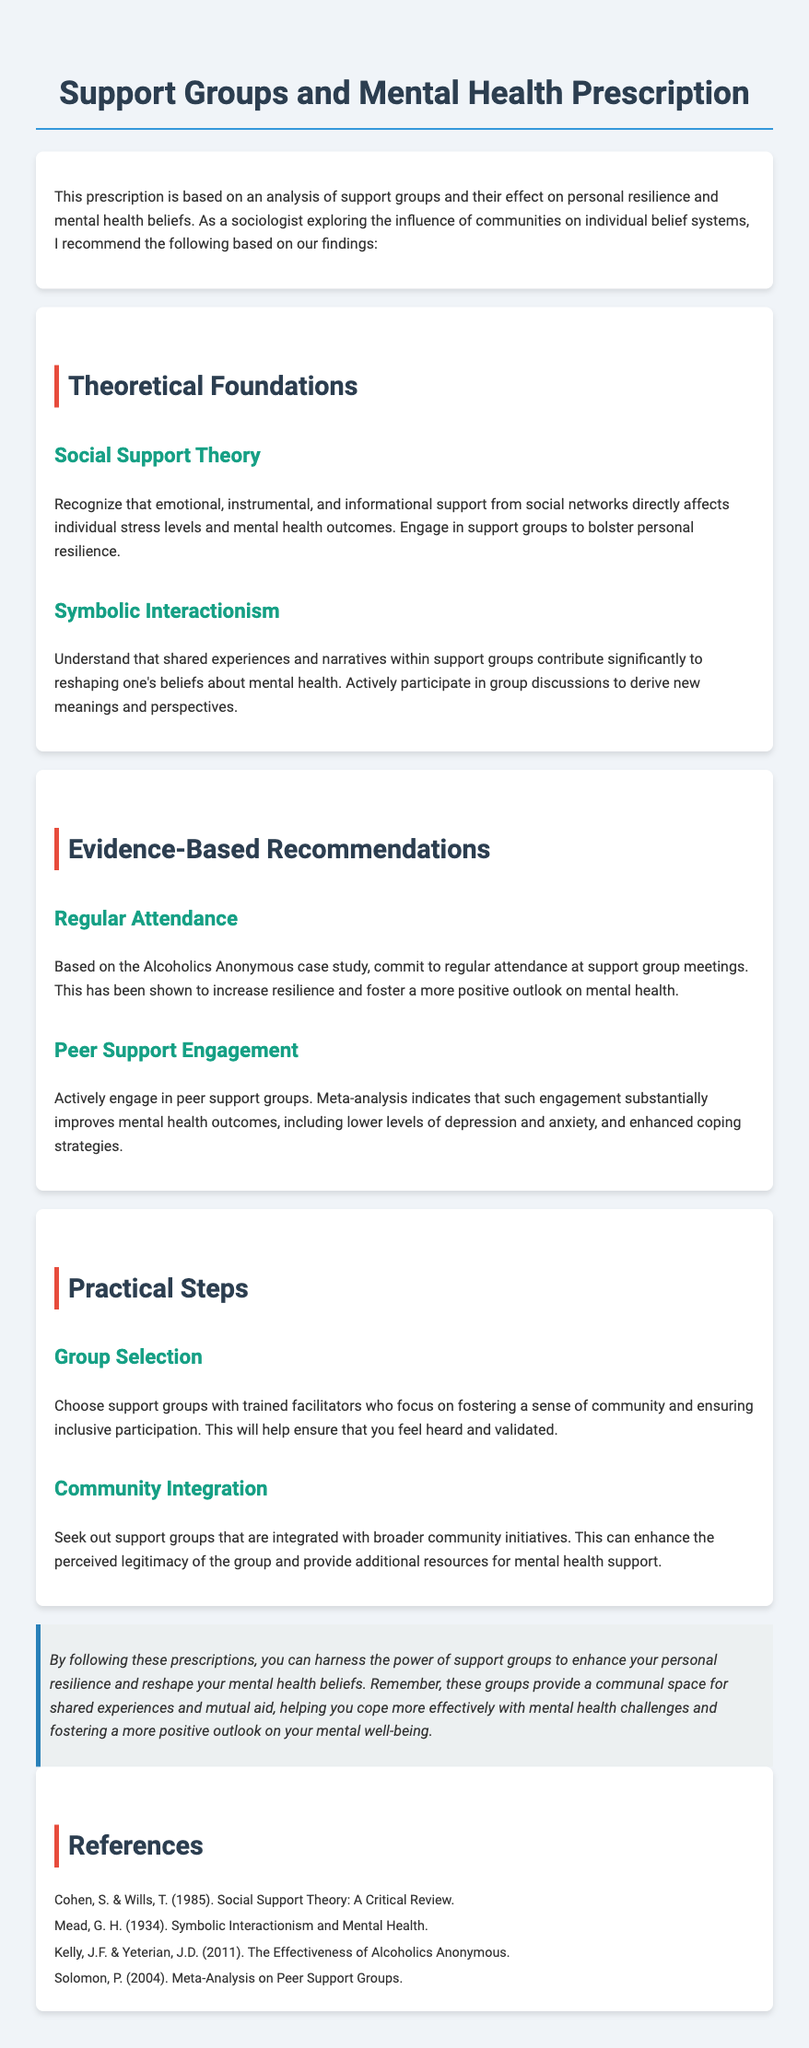What is the title of the document? The title appears at the top of the rendered document, indicating its focus on support groups and mental health.
Answer: Support Groups and Mental Health Prescription What theory suggests that social networks affect mental health? The theoretical foundations section provides insights into the importance of social networks in mental health, specifically through Social Support Theory.
Answer: Social Support Theory How often should one attend support group meetings according to the recommendations? The document specifically mentions the importance of regular attendance at support group meetings based on a case study.
Answer: Regular attendance What type of support group engagement is recommended for better mental health outcomes? The evidence-based recommendations highlight specific types of engagement that improve mental health outcomes, indicating the effectiveness of peer support.
Answer: Peer Support Engagement Which theory emphasizes the impact of shared experiences on beliefs about mental health? The theoretical foundations section discusses a theory that explains how interactions within groups contribute to changes in mental health beliefs.
Answer: Symbolic Interactionism What is a suggested practical step for selecting a support group? The practical steps section includes recommendations on selecting groups based on the involvement of trained facilitators.
Answer: Group Selection What should support groups be integrated with for enhanced legitimacy? The document suggests that the integration of support groups with broader initiatives can improve their perceived legitimacy.
Answer: Community initiatives What outcome is associated with regular attendance at support group meetings? The document states that regular attendance at meetings is correlated with fostering a more positive outlook on mental health.
Answer: More positive outlook Who authored a critical review of Social Support Theory referenced in the document? The references section lists authors who contributed to the foundational theories discussed, specifically Cohen and Wills.
Answer: Cohen, S. & Wills, T 